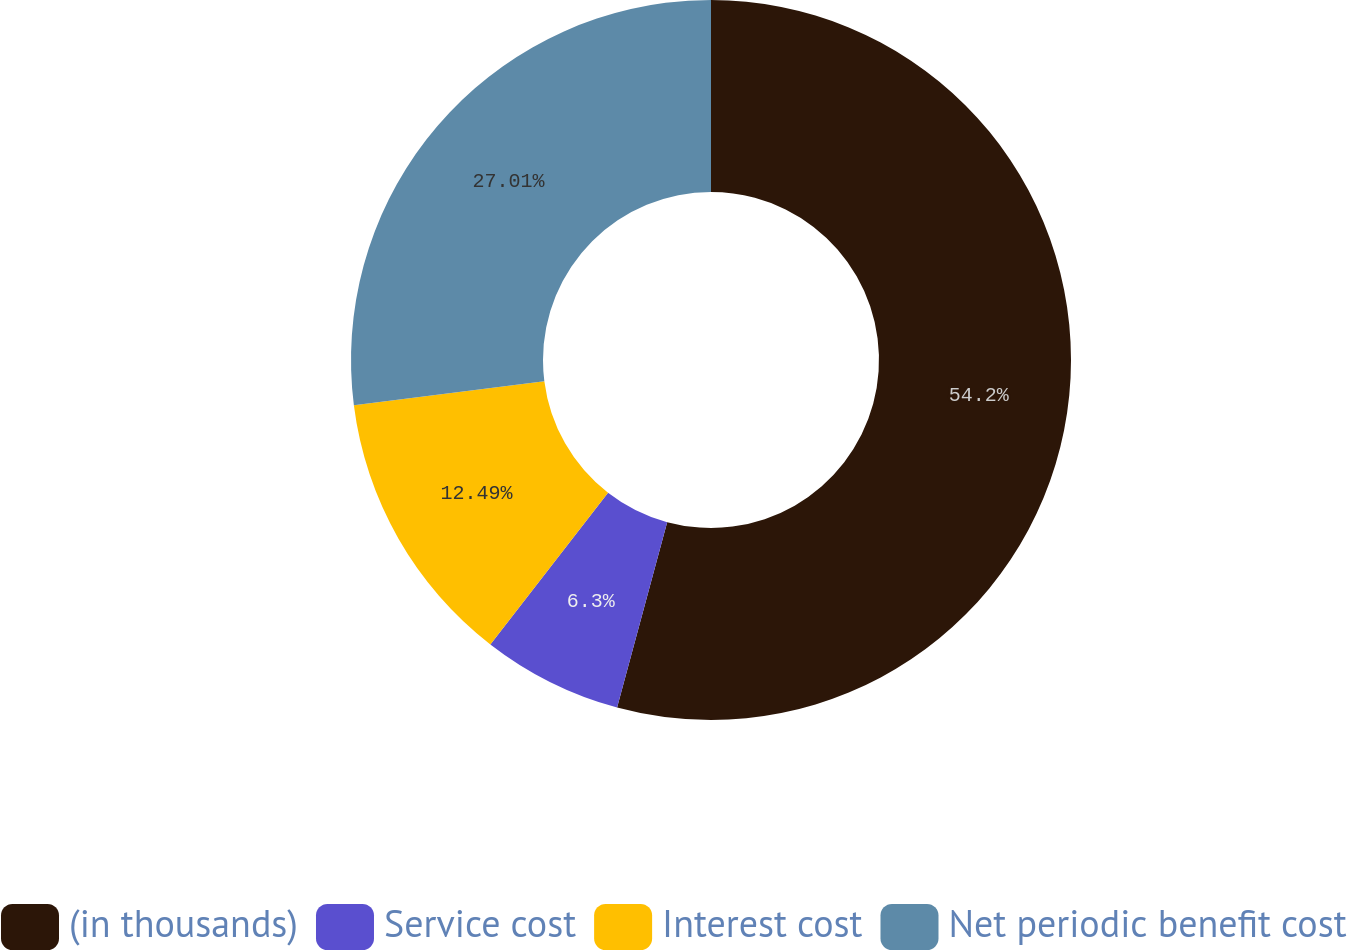Convert chart. <chart><loc_0><loc_0><loc_500><loc_500><pie_chart><fcel>(in thousands)<fcel>Service cost<fcel>Interest cost<fcel>Net periodic benefit cost<nl><fcel>54.2%<fcel>6.3%<fcel>12.49%<fcel>27.01%<nl></chart> 